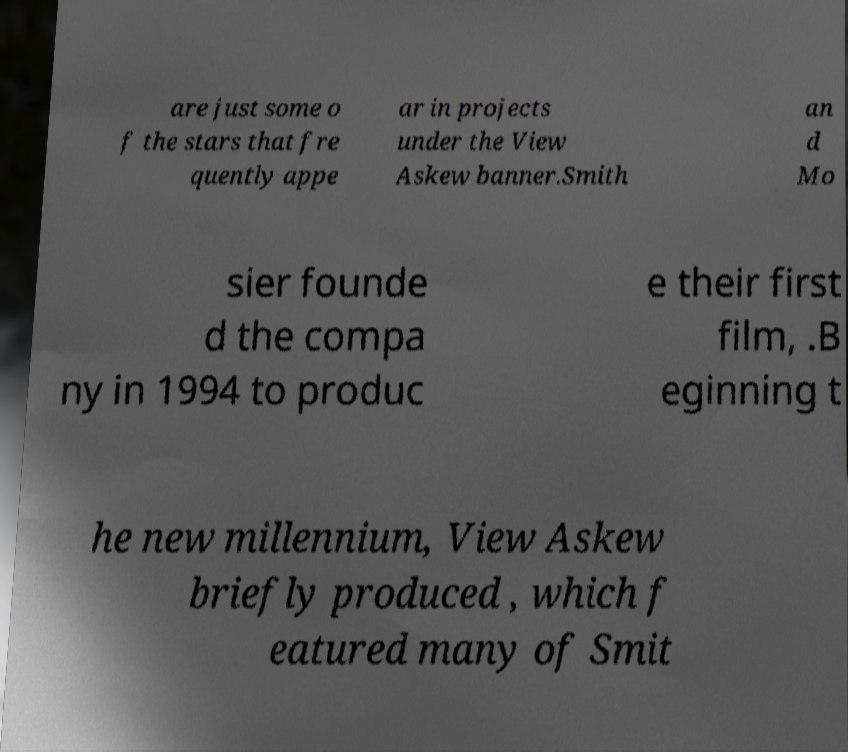There's text embedded in this image that I need extracted. Can you transcribe it verbatim? are just some o f the stars that fre quently appe ar in projects under the View Askew banner.Smith an d Mo sier founde d the compa ny in 1994 to produc e their first film, .B eginning t he new millennium, View Askew briefly produced , which f eatured many of Smit 